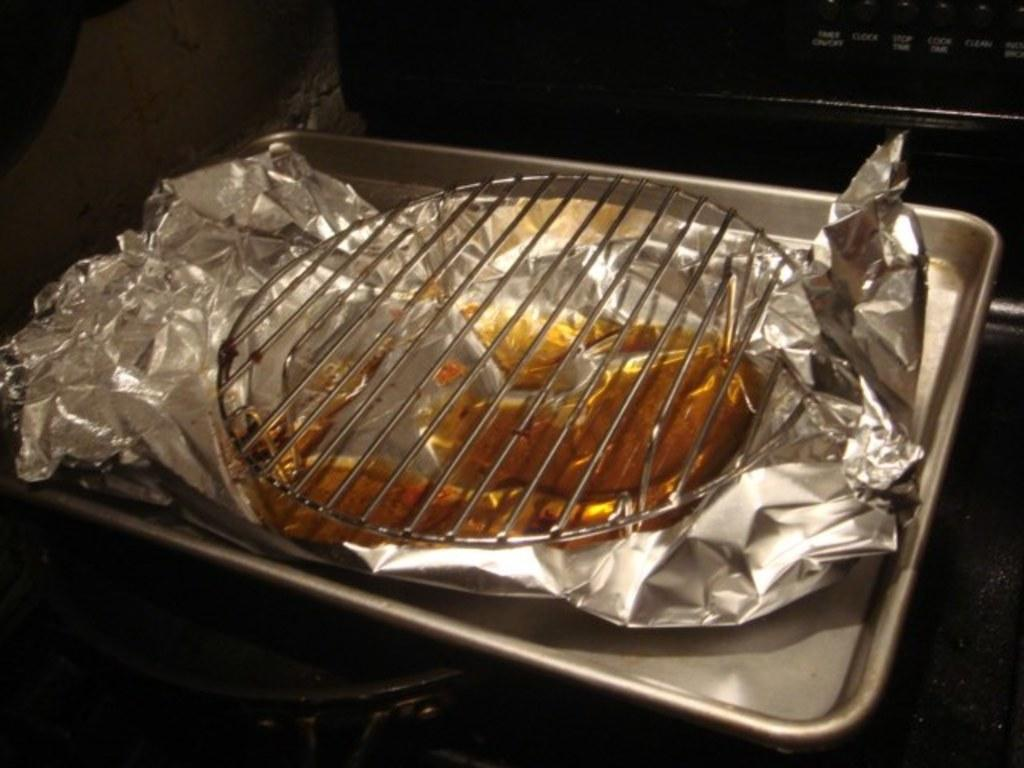What is the main subject of the image? The main subject of the image is food. How is the food being stored or protected? The food is covered in tin foil and has a lid covering it. Where is the food located? The food is present in a tray. What type of insurance policy is being discussed in the image? There is no mention of insurance in the image; it features food covered in tin foil and placed in a tray with a lid. Is the food sinking into quicksand in the image? There is no quicksand present in the image; the food is in a tray with a lid and covered in tin foil. 